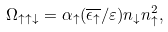Convert formula to latex. <formula><loc_0><loc_0><loc_500><loc_500>\Omega _ { \uparrow \uparrow \downarrow } = \alpha _ { \uparrow } ( \overline { \epsilon _ { \uparrow } } / \varepsilon ) n _ { \downarrow } n _ { \uparrow } ^ { 2 } ,</formula> 